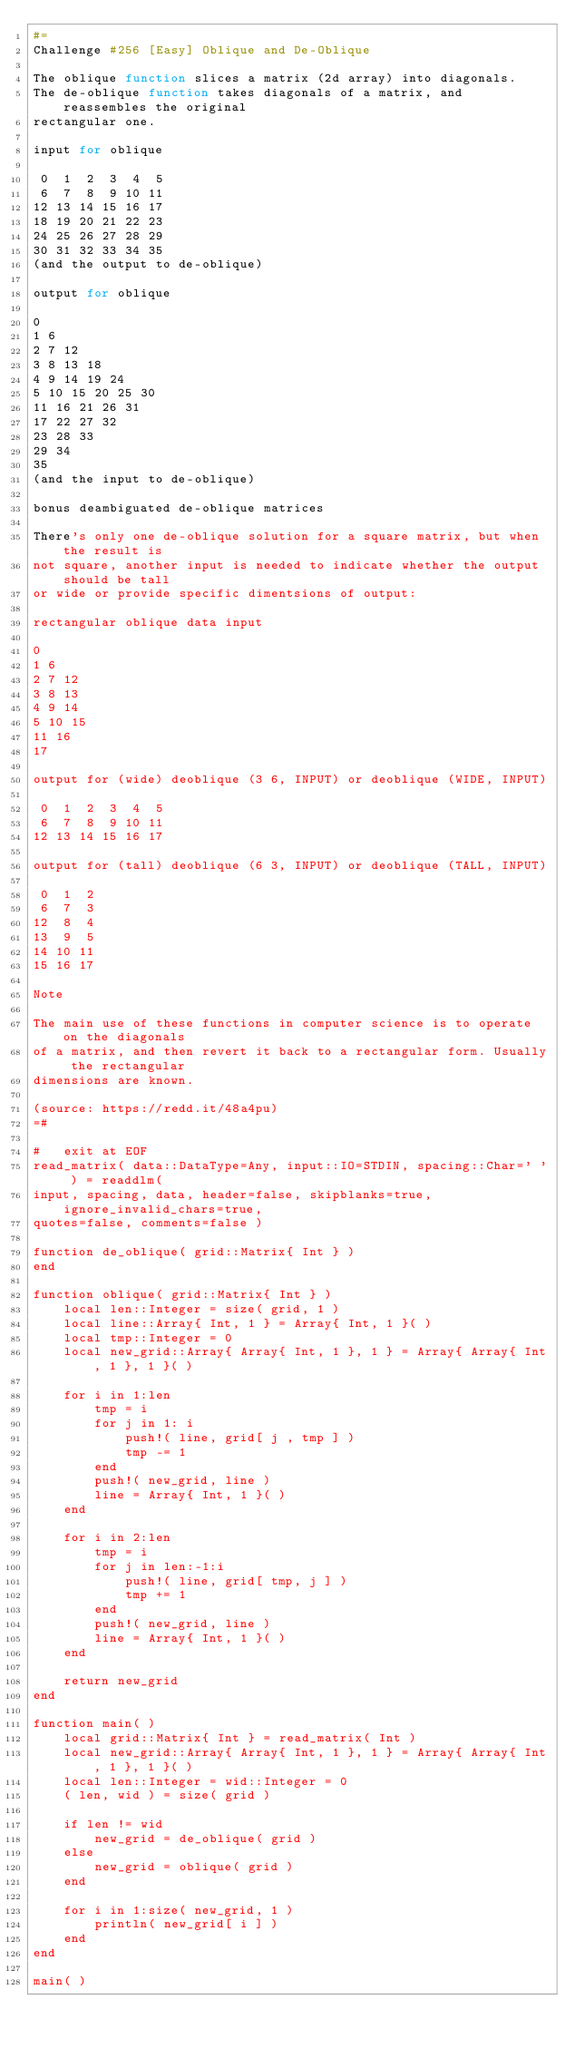<code> <loc_0><loc_0><loc_500><loc_500><_Julia_>#=
Challenge #256 [Easy] Oblique and De-Oblique

The oblique function slices a matrix (2d array) into diagonals.
The de-oblique function takes diagonals of a matrix, and reassembles the original
rectangular one.

input for oblique

 0  1  2  3  4  5
 6  7  8  9 10 11
12 13 14 15 16 17
18 19 20 21 22 23
24 25 26 27 28 29
30 31 32 33 34 35
(and the output to de-oblique)

output for oblique

0
1 6
2 7 12
3 8 13 18
4 9 14 19 24
5 10 15 20 25 30
11 16 21 26 31
17 22 27 32
23 28 33
29 34
35
(and the input to de-oblique)

bonus deambiguated de-oblique matrices

There's only one de-oblique solution for a square matrix, but when the result is
not square, another input is needed to indicate whether the output should be tall
or wide or provide specific dimentsions of output:

rectangular oblique data input

0
1 6
2 7 12
3 8 13
4 9 14
5 10 15
11 16
17

output for (wide) deoblique (3 6, INPUT) or deoblique (WIDE, INPUT)

 0  1  2  3  4  5
 6  7  8  9 10 11
12 13 14 15 16 17

output for (tall) deoblique (6 3, INPUT) or deoblique (TALL, INPUT)

 0  1  2
 6  7  3
12  8  4
13  9  5
14 10 11
15 16 17

Note

The main use of these functions in computer science is to operate on the diagonals
of a matrix, and then revert it back to a rectangular form. Usually the rectangular
dimensions are known.

(source: https://redd.it/48a4pu)
=#

#   exit at EOF
read_matrix( data::DataType=Any, input::IO=STDIN, spacing::Char=' ' ) = readdlm(
input, spacing, data, header=false, skipblanks=true, ignore_invalid_chars=true,
quotes=false, comments=false )

function de_oblique( grid::Matrix{ Int } )
end

function oblique( grid::Matrix{ Int } )
    local len::Integer = size( grid, 1 )
    local line::Array{ Int, 1 } = Array{ Int, 1 }( )
    local tmp::Integer = 0
    local new_grid::Array{ Array{ Int, 1 }, 1 } = Array{ Array{ Int, 1 }, 1 }( )

    for i in 1:len
        tmp = i
        for j in 1: i
            push!( line, grid[ j , tmp ] )
            tmp -= 1
        end
        push!( new_grid, line )
        line = Array{ Int, 1 }( )
    end

    for i in 2:len
        tmp = i
        for j in len:-1:i
            push!( line, grid[ tmp, j ] )
            tmp += 1
        end
        push!( new_grid, line )
        line = Array{ Int, 1 }( )
    end

    return new_grid
end

function main( )
    local grid::Matrix{ Int } = read_matrix( Int )
    local new_grid::Array{ Array{ Int, 1 }, 1 } = Array{ Array{ Int, 1 }, 1 }( )
    local len::Integer = wid::Integer = 0
    ( len, wid ) = size( grid )

    if len != wid
        new_grid = de_oblique( grid )
    else
        new_grid = oblique( grid )
    end

    for i in 1:size( new_grid, 1 )
        println( new_grid[ i ] )
    end
end

main( )
</code> 